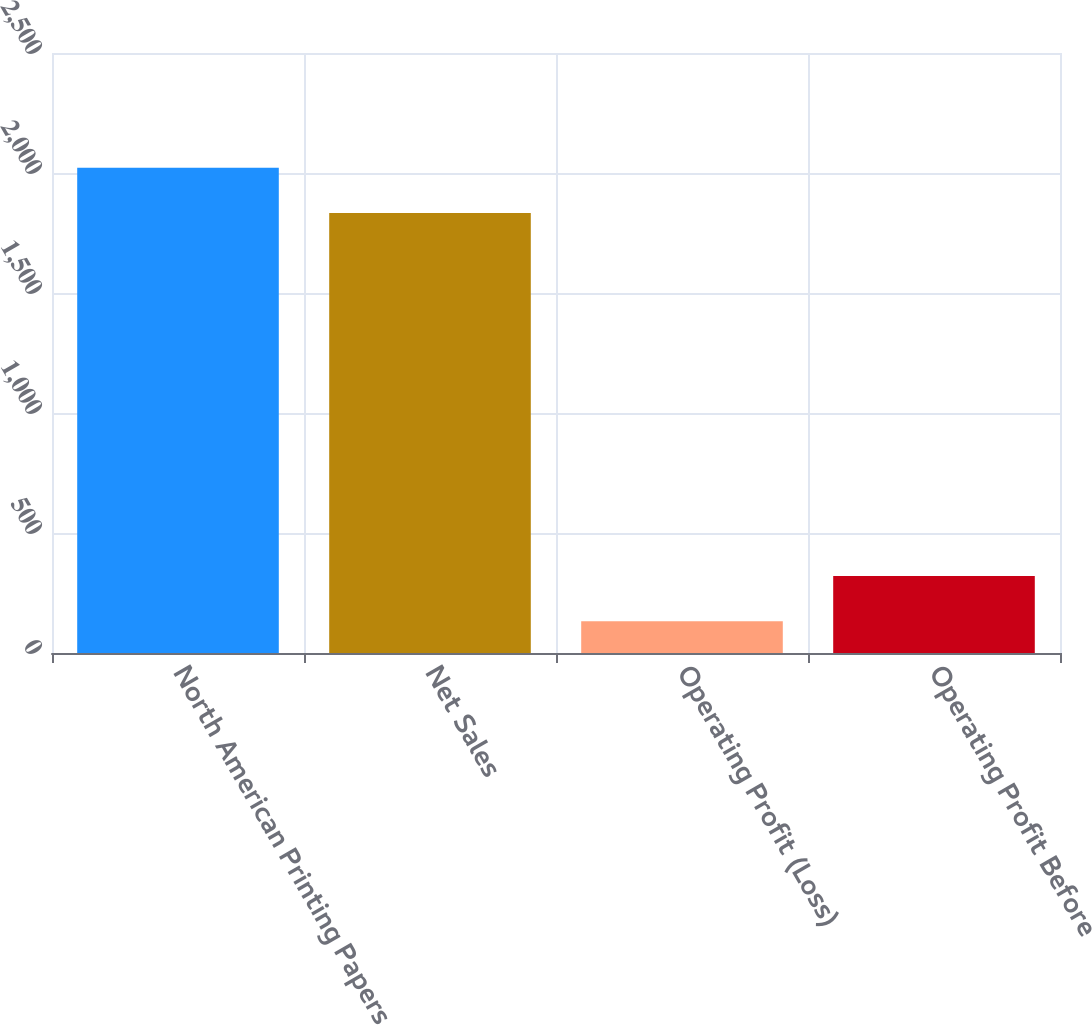Convert chart. <chart><loc_0><loc_0><loc_500><loc_500><bar_chart><fcel>North American Printing Papers<fcel>Net Sales<fcel>Operating Profit (Loss)<fcel>Operating Profit Before<nl><fcel>2021.5<fcel>1833<fcel>132<fcel>320.5<nl></chart> 